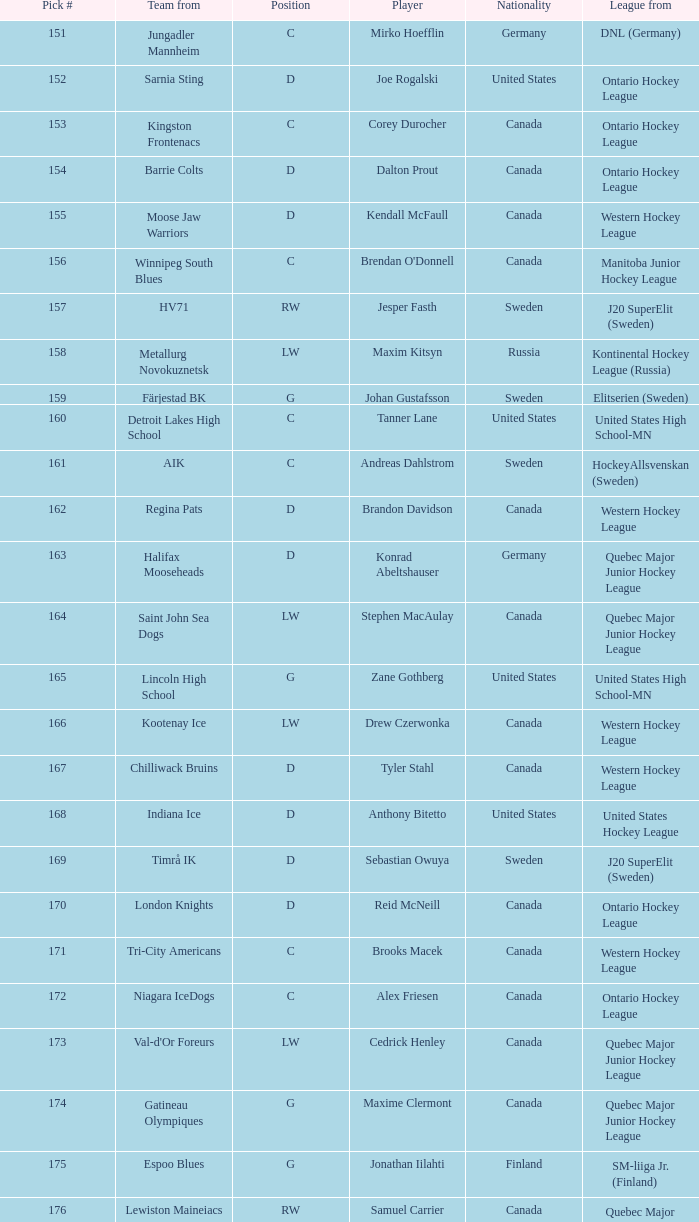What is the position of the team player from Aik? C. 